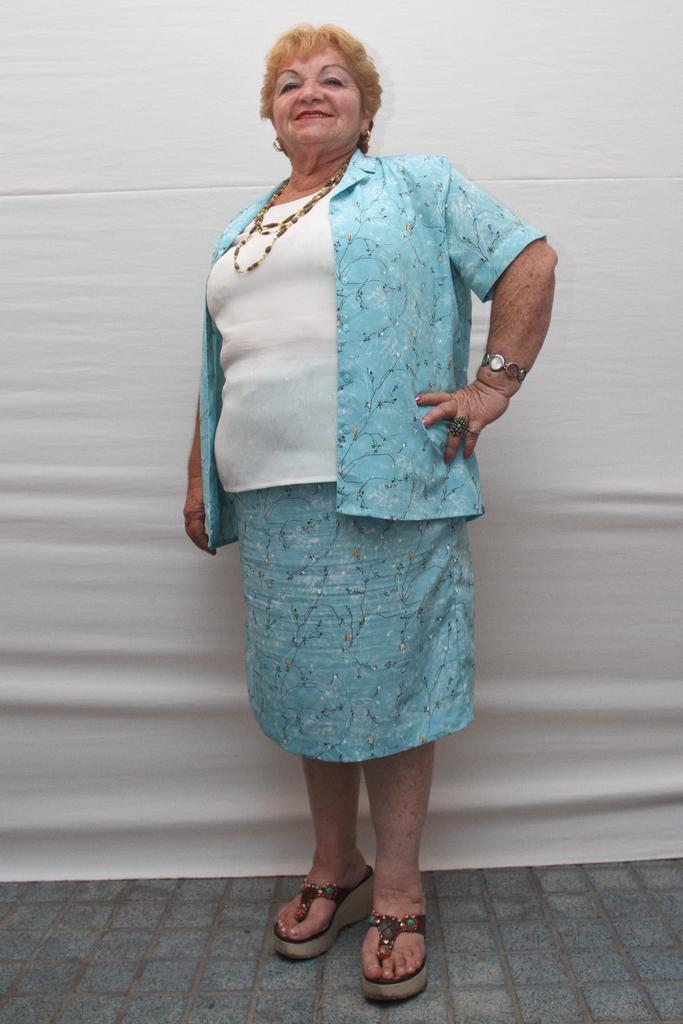Could you give a brief overview of what you see in this image? In this image, we can see a lady standing. We can also see the ground. We can see the white background. 